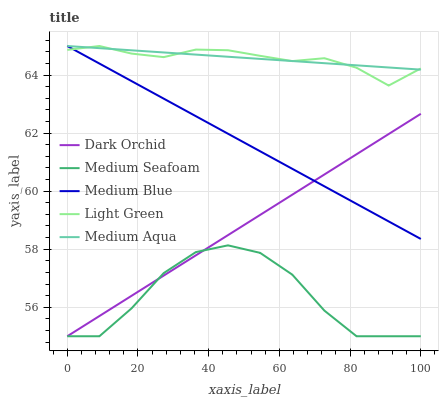Does Medium Seafoam have the minimum area under the curve?
Answer yes or no. Yes. Does Medium Aqua have the maximum area under the curve?
Answer yes or no. Yes. Does Light Green have the minimum area under the curve?
Answer yes or no. No. Does Light Green have the maximum area under the curve?
Answer yes or no. No. Is Dark Orchid the smoothest?
Answer yes or no. Yes. Is Medium Seafoam the roughest?
Answer yes or no. Yes. Is Light Green the smoothest?
Answer yes or no. No. Is Light Green the roughest?
Answer yes or no. No. Does Medium Seafoam have the lowest value?
Answer yes or no. Yes. Does Light Green have the lowest value?
Answer yes or no. No. Does Medium Blue have the highest value?
Answer yes or no. Yes. Does Medium Seafoam have the highest value?
Answer yes or no. No. Is Dark Orchid less than Medium Aqua?
Answer yes or no. Yes. Is Medium Blue greater than Medium Seafoam?
Answer yes or no. Yes. Does Medium Blue intersect Medium Aqua?
Answer yes or no. Yes. Is Medium Blue less than Medium Aqua?
Answer yes or no. No. Is Medium Blue greater than Medium Aqua?
Answer yes or no. No. Does Dark Orchid intersect Medium Aqua?
Answer yes or no. No. 